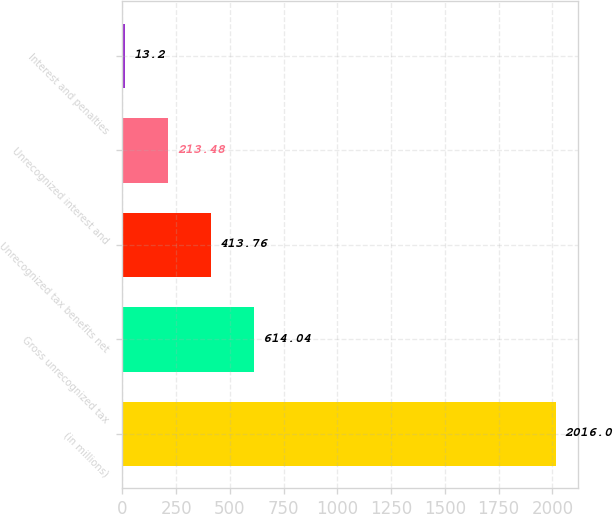Convert chart to OTSL. <chart><loc_0><loc_0><loc_500><loc_500><bar_chart><fcel>(in millions)<fcel>Gross unrecognized tax<fcel>Unrecognized tax benefits net<fcel>Unrecognized interest and<fcel>Interest and penalties<nl><fcel>2016<fcel>614.04<fcel>413.76<fcel>213.48<fcel>13.2<nl></chart> 